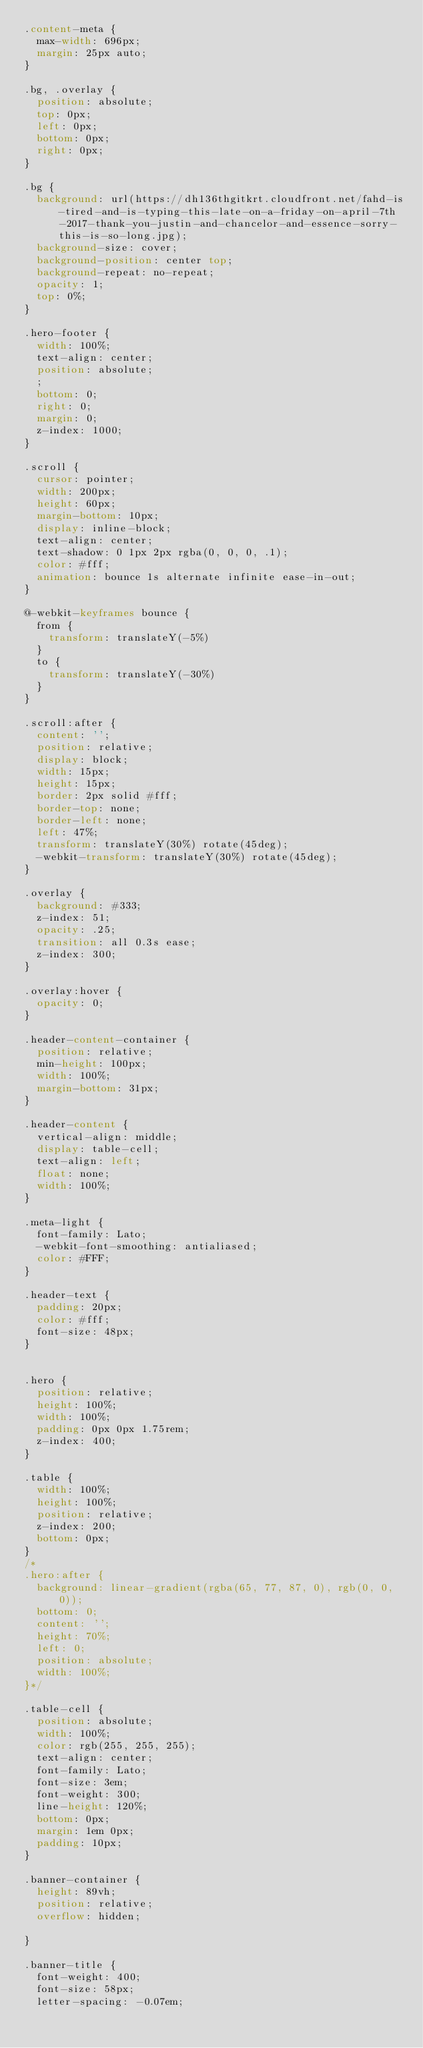<code> <loc_0><loc_0><loc_500><loc_500><_CSS_>.content-meta {
  max-width: 696px;
  margin: 25px auto;
}

.bg, .overlay {
  position: absolute;
  top: 0px;
  left: 0px;
  bottom: 0px;
  right: 0px;
}

.bg {
  background: url(https://dh136thgitkrt.cloudfront.net/fahd-is-tired-and-is-typing-this-late-on-a-friday-on-april-7th-2017-thank-you-justin-and-chancelor-and-essence-sorry-this-is-so-long.jpg);
  background-size: cover;
  background-position: center top;
  background-repeat: no-repeat;
  opacity: 1;
  top: 0%;
}

.hero-footer {
  width: 100%;
  text-align: center;
  position: absolute;
  ;
  bottom: 0;
  right: 0;
  margin: 0;
  z-index: 1000;
}

.scroll {
  cursor: pointer;
  width: 200px;
  height: 60px;
  margin-bottom: 10px;
  display: inline-block;
  text-align: center;
  text-shadow: 0 1px 2px rgba(0, 0, 0, .1);
  color: #fff;
  animation: bounce 1s alternate infinite ease-in-out;
}

@-webkit-keyframes bounce {
  from {
    transform: translateY(-5%)
  }
  to {
    transform: translateY(-30%)
  }
}

.scroll:after {
  content: '';
  position: relative;
  display: block;
  width: 15px;
  height: 15px;
  border: 2px solid #fff;
  border-top: none;
  border-left: none;
  left: 47%;
  transform: translateY(30%) rotate(45deg);
  -webkit-transform: translateY(30%) rotate(45deg);
}

.overlay {
  background: #333;
  z-index: 51;
  opacity: .25;
  transition: all 0.3s ease;
  z-index: 300;
}

.overlay:hover {
  opacity: 0;
}

.header-content-container {
  position: relative;
  min-height: 100px;
  width: 100%;
  margin-bottom: 31px;
}

.header-content {
  vertical-align: middle;
  display: table-cell;
  text-align: left;
  float: none;
  width: 100%;
}

.meta-light {
  font-family: Lato;
  -webkit-font-smoothing: antialiased;
  color: #FFF;
}

.header-text {
  padding: 20px;
  color: #fff;
  font-size: 48px;
}


.hero {
  position: relative;
  height: 100%;
  width: 100%;
  padding: 0px 0px 1.75rem;
  z-index: 400;
}

.table {
  width: 100%;
  height: 100%;
  position: relative;
  z-index: 200;
  bottom: 0px;
}
/*
.hero:after {
  background: linear-gradient(rgba(65, 77, 87, 0), rgb(0, 0, 0));
  bottom: 0;
  content: '';
  height: 70%;
  left: 0;
  position: absolute;
  width: 100%;
}*/

.table-cell {
  position: absolute;
  width: 100%;
  color: rgb(255, 255, 255);
  text-align: center;
  font-family: Lato;
  font-size: 3em;
  font-weight: 300;
  line-height: 120%;
  bottom: 0px;
  margin: 1em 0px;
  padding: 10px;
}

.banner-container {
  height: 89vh;
  position: relative;
  overflow: hidden;

}

.banner-title {
  font-weight: 400;
  font-size: 58px;
  letter-spacing: -0.07em;</code> 